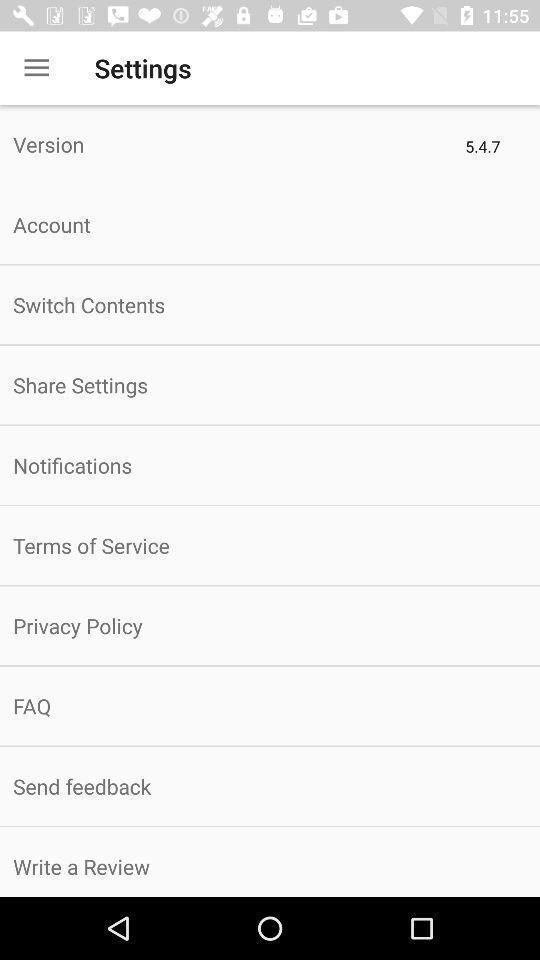Explain what's happening in this screen capture. Settings page with various other options. 